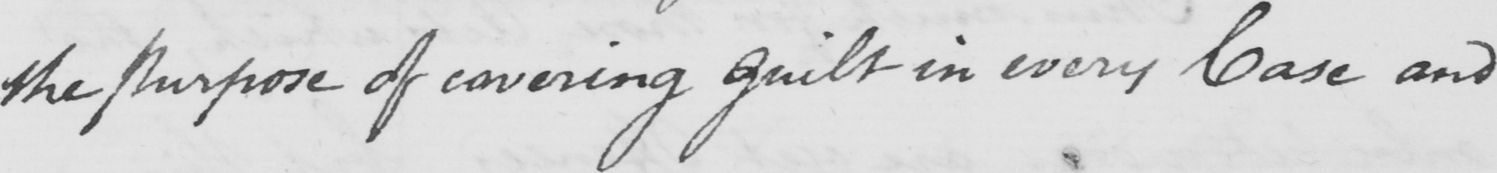What text is written in this handwritten line? the purpose of covering guilt in every Case and 